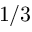Convert formula to latex. <formula><loc_0><loc_0><loc_500><loc_500>1 / 3</formula> 